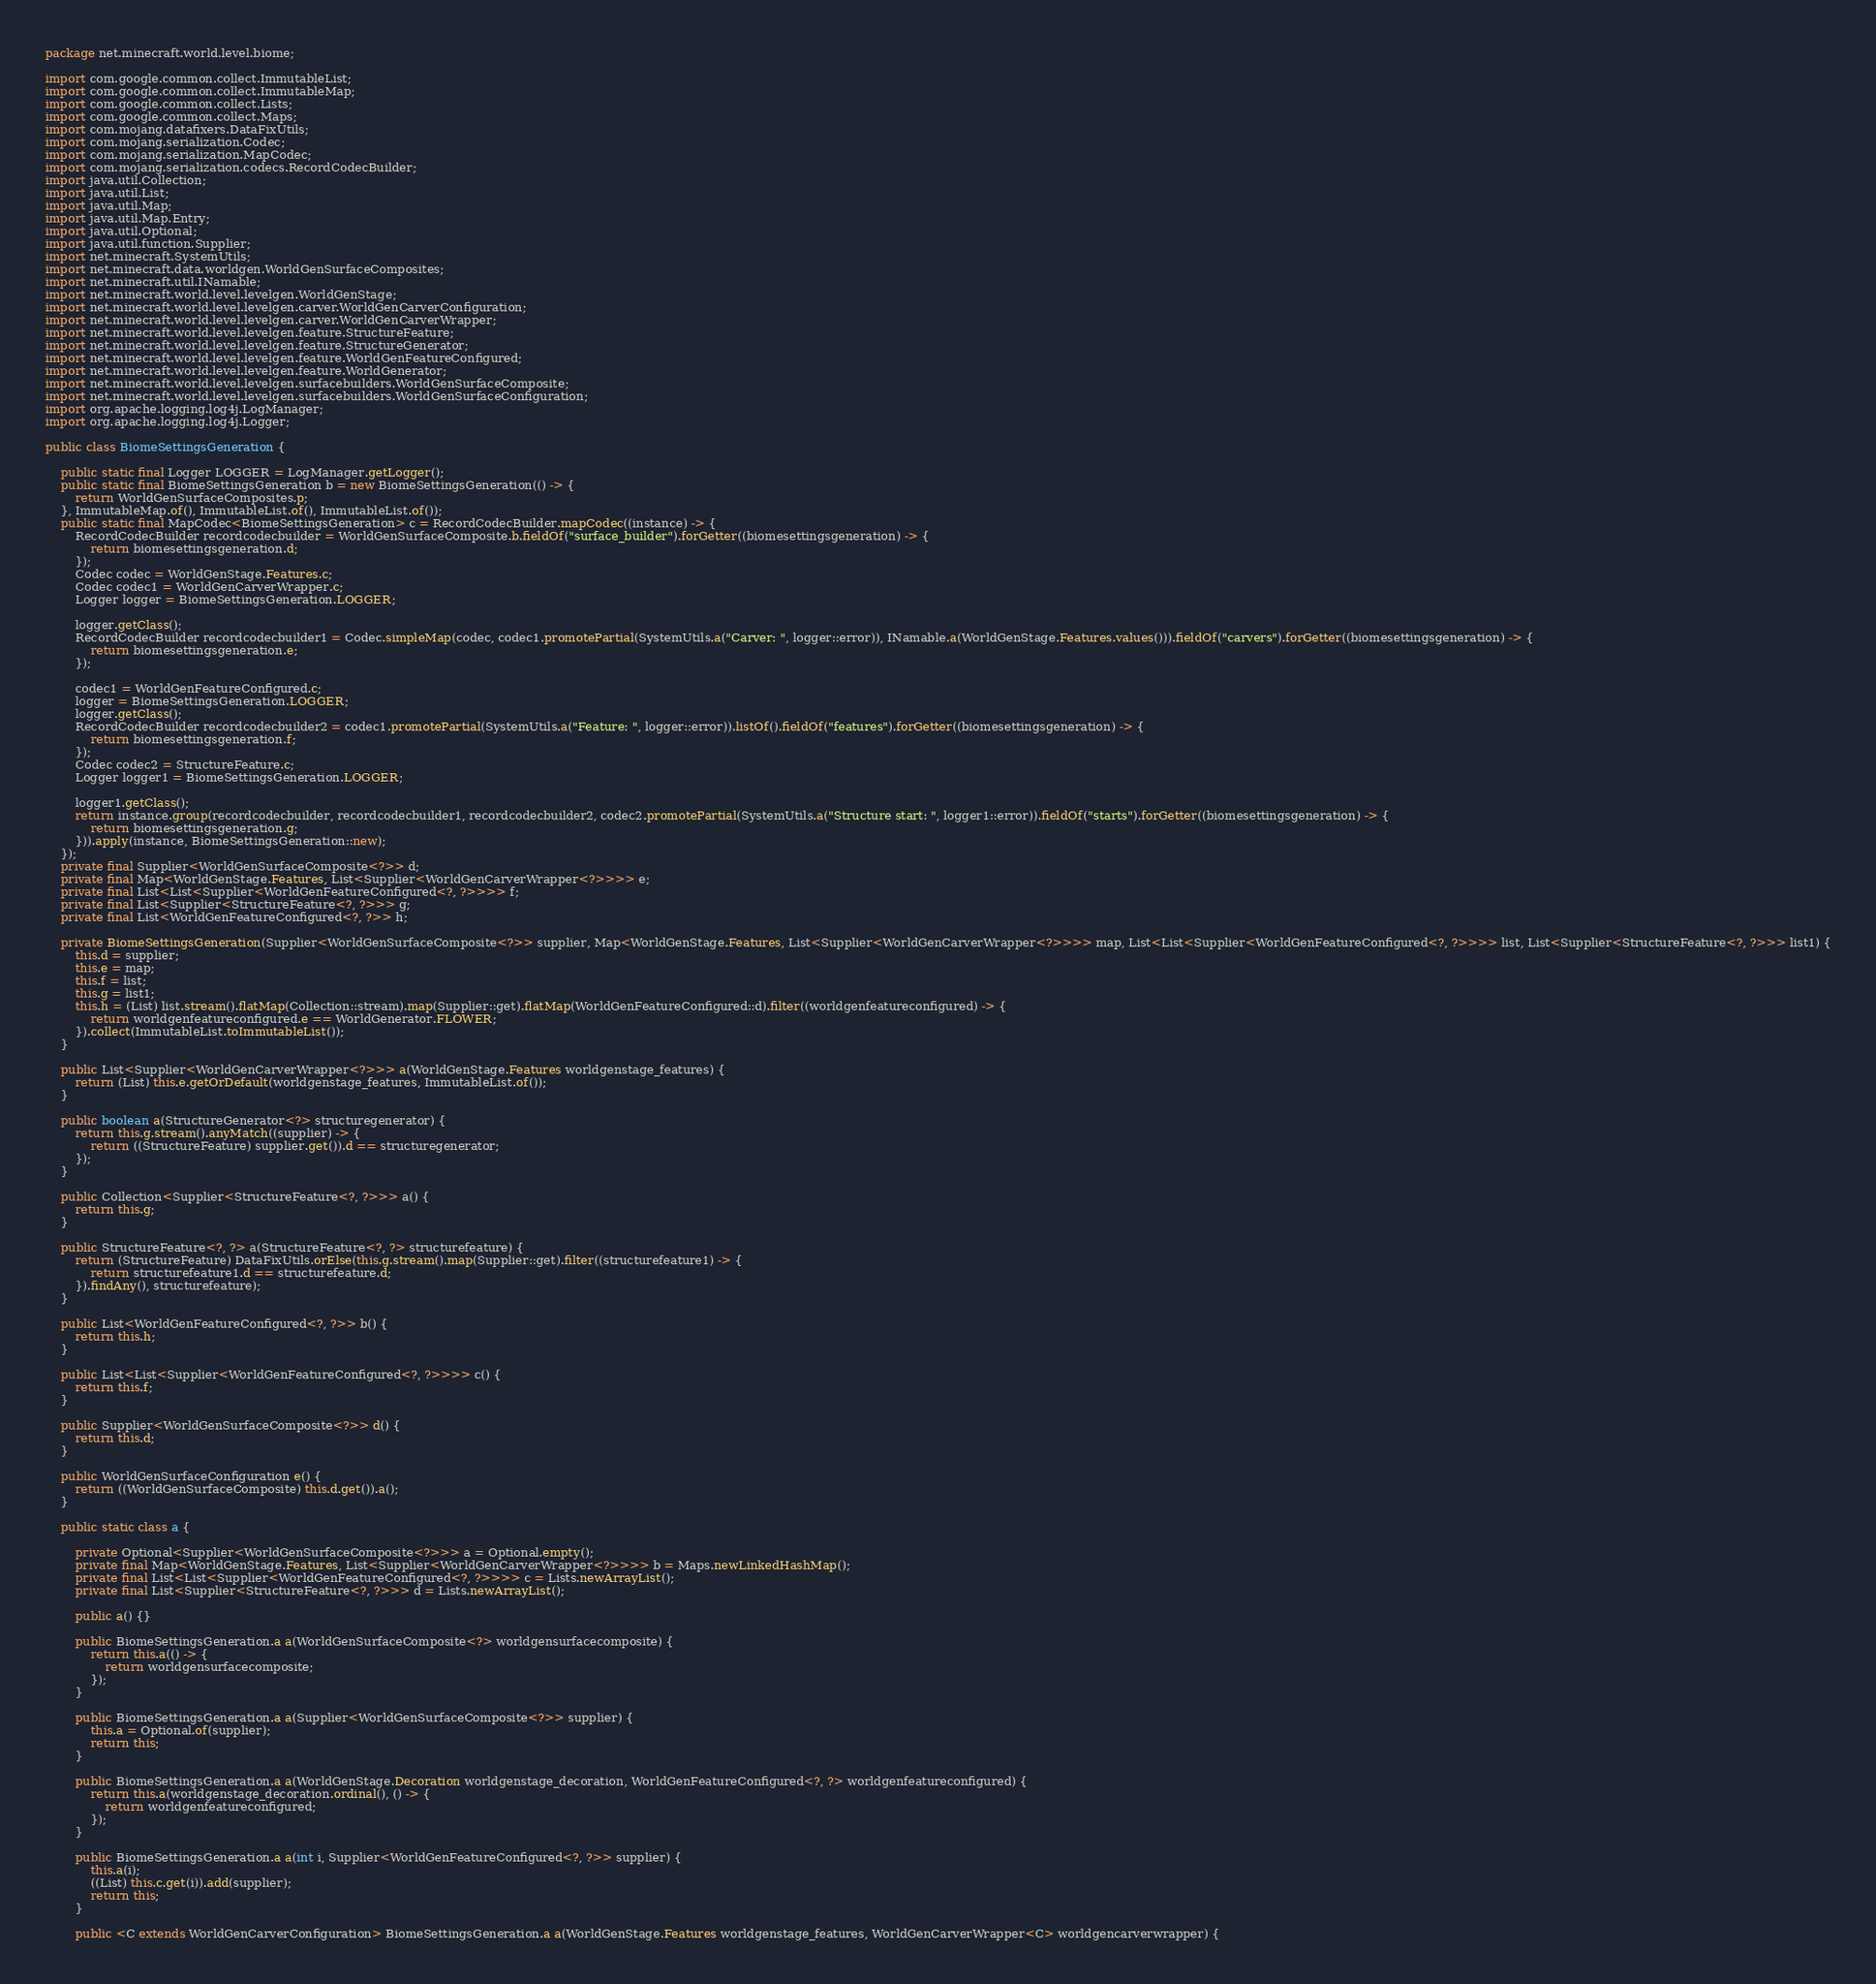<code> <loc_0><loc_0><loc_500><loc_500><_Java_>package net.minecraft.world.level.biome;

import com.google.common.collect.ImmutableList;
import com.google.common.collect.ImmutableMap;
import com.google.common.collect.Lists;
import com.google.common.collect.Maps;
import com.mojang.datafixers.DataFixUtils;
import com.mojang.serialization.Codec;
import com.mojang.serialization.MapCodec;
import com.mojang.serialization.codecs.RecordCodecBuilder;
import java.util.Collection;
import java.util.List;
import java.util.Map;
import java.util.Map.Entry;
import java.util.Optional;
import java.util.function.Supplier;
import net.minecraft.SystemUtils;
import net.minecraft.data.worldgen.WorldGenSurfaceComposites;
import net.minecraft.util.INamable;
import net.minecraft.world.level.levelgen.WorldGenStage;
import net.minecraft.world.level.levelgen.carver.WorldGenCarverConfiguration;
import net.minecraft.world.level.levelgen.carver.WorldGenCarverWrapper;
import net.minecraft.world.level.levelgen.feature.StructureFeature;
import net.minecraft.world.level.levelgen.feature.StructureGenerator;
import net.minecraft.world.level.levelgen.feature.WorldGenFeatureConfigured;
import net.minecraft.world.level.levelgen.feature.WorldGenerator;
import net.minecraft.world.level.levelgen.surfacebuilders.WorldGenSurfaceComposite;
import net.minecraft.world.level.levelgen.surfacebuilders.WorldGenSurfaceConfiguration;
import org.apache.logging.log4j.LogManager;
import org.apache.logging.log4j.Logger;

public class BiomeSettingsGeneration {

    public static final Logger LOGGER = LogManager.getLogger();
    public static final BiomeSettingsGeneration b = new BiomeSettingsGeneration(() -> {
        return WorldGenSurfaceComposites.p;
    }, ImmutableMap.of(), ImmutableList.of(), ImmutableList.of());
    public static final MapCodec<BiomeSettingsGeneration> c = RecordCodecBuilder.mapCodec((instance) -> {
        RecordCodecBuilder recordcodecbuilder = WorldGenSurfaceComposite.b.fieldOf("surface_builder").forGetter((biomesettingsgeneration) -> {
            return biomesettingsgeneration.d;
        });
        Codec codec = WorldGenStage.Features.c;
        Codec codec1 = WorldGenCarverWrapper.c;
        Logger logger = BiomeSettingsGeneration.LOGGER;

        logger.getClass();
        RecordCodecBuilder recordcodecbuilder1 = Codec.simpleMap(codec, codec1.promotePartial(SystemUtils.a("Carver: ", logger::error)), INamable.a(WorldGenStage.Features.values())).fieldOf("carvers").forGetter((biomesettingsgeneration) -> {
            return biomesettingsgeneration.e;
        });

        codec1 = WorldGenFeatureConfigured.c;
        logger = BiomeSettingsGeneration.LOGGER;
        logger.getClass();
        RecordCodecBuilder recordcodecbuilder2 = codec1.promotePartial(SystemUtils.a("Feature: ", logger::error)).listOf().fieldOf("features").forGetter((biomesettingsgeneration) -> {
            return biomesettingsgeneration.f;
        });
        Codec codec2 = StructureFeature.c;
        Logger logger1 = BiomeSettingsGeneration.LOGGER;

        logger1.getClass();
        return instance.group(recordcodecbuilder, recordcodecbuilder1, recordcodecbuilder2, codec2.promotePartial(SystemUtils.a("Structure start: ", logger1::error)).fieldOf("starts").forGetter((biomesettingsgeneration) -> {
            return biomesettingsgeneration.g;
        })).apply(instance, BiomeSettingsGeneration::new);
    });
    private final Supplier<WorldGenSurfaceComposite<?>> d;
    private final Map<WorldGenStage.Features, List<Supplier<WorldGenCarverWrapper<?>>>> e;
    private final List<List<Supplier<WorldGenFeatureConfigured<?, ?>>>> f;
    private final List<Supplier<StructureFeature<?, ?>>> g;
    private final List<WorldGenFeatureConfigured<?, ?>> h;

    private BiomeSettingsGeneration(Supplier<WorldGenSurfaceComposite<?>> supplier, Map<WorldGenStage.Features, List<Supplier<WorldGenCarverWrapper<?>>>> map, List<List<Supplier<WorldGenFeatureConfigured<?, ?>>>> list, List<Supplier<StructureFeature<?, ?>>> list1) {
        this.d = supplier;
        this.e = map;
        this.f = list;
        this.g = list1;
        this.h = (List) list.stream().flatMap(Collection::stream).map(Supplier::get).flatMap(WorldGenFeatureConfigured::d).filter((worldgenfeatureconfigured) -> {
            return worldgenfeatureconfigured.e == WorldGenerator.FLOWER;
        }).collect(ImmutableList.toImmutableList());
    }

    public List<Supplier<WorldGenCarverWrapper<?>>> a(WorldGenStage.Features worldgenstage_features) {
        return (List) this.e.getOrDefault(worldgenstage_features, ImmutableList.of());
    }

    public boolean a(StructureGenerator<?> structuregenerator) {
        return this.g.stream().anyMatch((supplier) -> {
            return ((StructureFeature) supplier.get()).d == structuregenerator;
        });
    }

    public Collection<Supplier<StructureFeature<?, ?>>> a() {
        return this.g;
    }

    public StructureFeature<?, ?> a(StructureFeature<?, ?> structurefeature) {
        return (StructureFeature) DataFixUtils.orElse(this.g.stream().map(Supplier::get).filter((structurefeature1) -> {
            return structurefeature1.d == structurefeature.d;
        }).findAny(), structurefeature);
    }

    public List<WorldGenFeatureConfigured<?, ?>> b() {
        return this.h;
    }

    public List<List<Supplier<WorldGenFeatureConfigured<?, ?>>>> c() {
        return this.f;
    }

    public Supplier<WorldGenSurfaceComposite<?>> d() {
        return this.d;
    }

    public WorldGenSurfaceConfiguration e() {
        return ((WorldGenSurfaceComposite) this.d.get()).a();
    }

    public static class a {

        private Optional<Supplier<WorldGenSurfaceComposite<?>>> a = Optional.empty();
        private final Map<WorldGenStage.Features, List<Supplier<WorldGenCarverWrapper<?>>>> b = Maps.newLinkedHashMap();
        private final List<List<Supplier<WorldGenFeatureConfigured<?, ?>>>> c = Lists.newArrayList();
        private final List<Supplier<StructureFeature<?, ?>>> d = Lists.newArrayList();

        public a() {}

        public BiomeSettingsGeneration.a a(WorldGenSurfaceComposite<?> worldgensurfacecomposite) {
            return this.a(() -> {
                return worldgensurfacecomposite;
            });
        }

        public BiomeSettingsGeneration.a a(Supplier<WorldGenSurfaceComposite<?>> supplier) {
            this.a = Optional.of(supplier);
            return this;
        }

        public BiomeSettingsGeneration.a a(WorldGenStage.Decoration worldgenstage_decoration, WorldGenFeatureConfigured<?, ?> worldgenfeatureconfigured) {
            return this.a(worldgenstage_decoration.ordinal(), () -> {
                return worldgenfeatureconfigured;
            });
        }

        public BiomeSettingsGeneration.a a(int i, Supplier<WorldGenFeatureConfigured<?, ?>> supplier) {
            this.a(i);
            ((List) this.c.get(i)).add(supplier);
            return this;
        }

        public <C extends WorldGenCarverConfiguration> BiomeSettingsGeneration.a a(WorldGenStage.Features worldgenstage_features, WorldGenCarverWrapper<C> worldgencarverwrapper) {</code> 